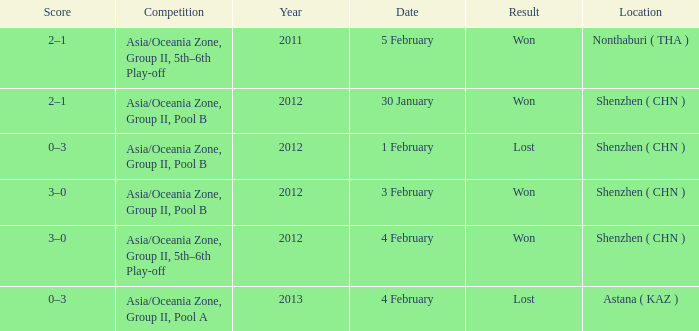What is the sum of the year for 5 february? 2011.0. 